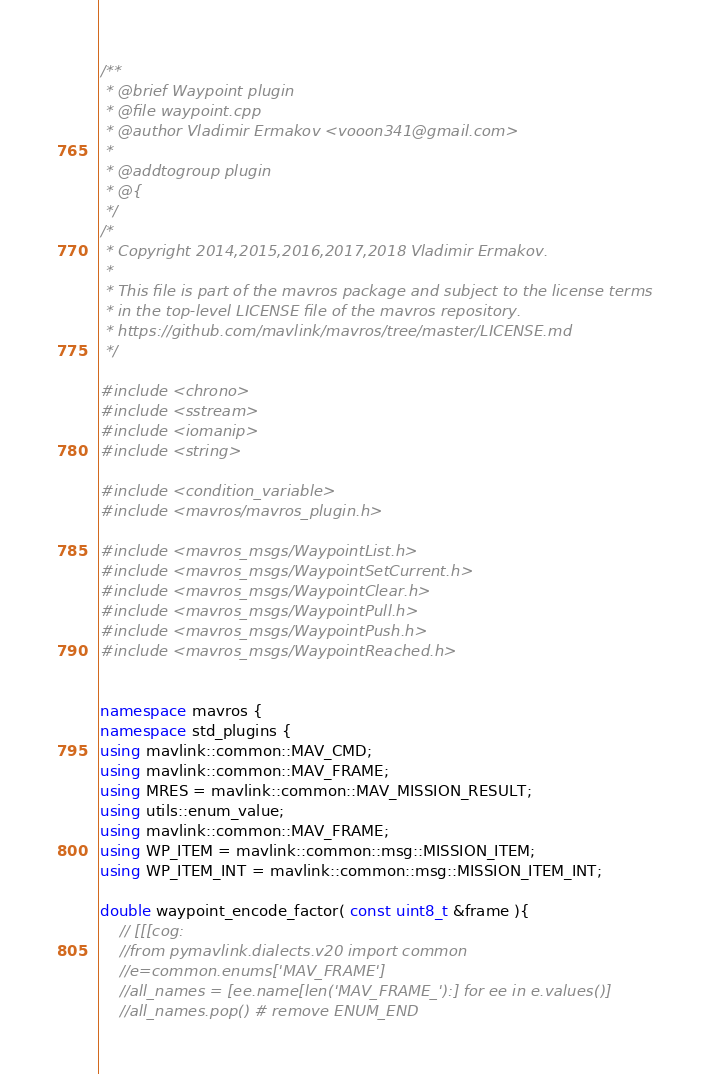<code> <loc_0><loc_0><loc_500><loc_500><_C++_>/**
 * @brief Waypoint plugin
 * @file waypoint.cpp
 * @author Vladimir Ermakov <vooon341@gmail.com>
 *
 * @addtogroup plugin
 * @{
 */
/*
 * Copyright 2014,2015,2016,2017,2018 Vladimir Ermakov.
 *
 * This file is part of the mavros package and subject to the license terms
 * in the top-level LICENSE file of the mavros repository.
 * https://github.com/mavlink/mavros/tree/master/LICENSE.md
 */

#include <chrono>
#include <sstream>
#include <iomanip>
#include <string>

#include <condition_variable>
#include <mavros/mavros_plugin.h>

#include <mavros_msgs/WaypointList.h>
#include <mavros_msgs/WaypointSetCurrent.h>
#include <mavros_msgs/WaypointClear.h>
#include <mavros_msgs/WaypointPull.h>
#include <mavros_msgs/WaypointPush.h>
#include <mavros_msgs/WaypointReached.h>


namespace mavros {
namespace std_plugins {
using mavlink::common::MAV_CMD;
using mavlink::common::MAV_FRAME;
using MRES = mavlink::common::MAV_MISSION_RESULT;
using utils::enum_value;
using mavlink::common::MAV_FRAME;
using WP_ITEM = mavlink::common::msg::MISSION_ITEM;
using WP_ITEM_INT = mavlink::common::msg::MISSION_ITEM_INT;

double waypoint_encode_factor( const uint8_t &frame ){
	// [[[cog:
	//from pymavlink.dialects.v20 import common
	//e=common.enums['MAV_FRAME']
	//all_names = [ee.name[len('MAV_FRAME_'):] for ee in e.values()]
	//all_names.pop() # remove ENUM_END</code> 